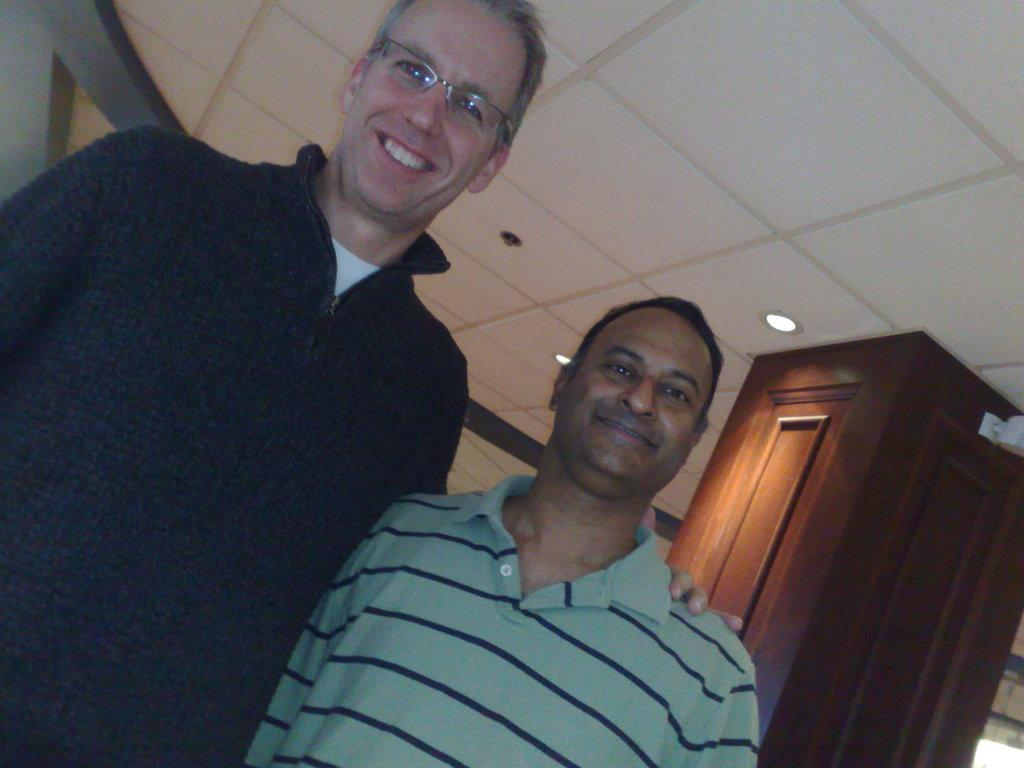What is the main subject in the center of the image? There are men in the center of the image. What can be seen in the background of the image? There is a wooden pillar and lamps in the background of the image. How many ladybugs can be seen on the wooden pillar in the image? There are no ladybugs present in the image, as it only features men in the center and a wooden pillar and lamps in the background. 